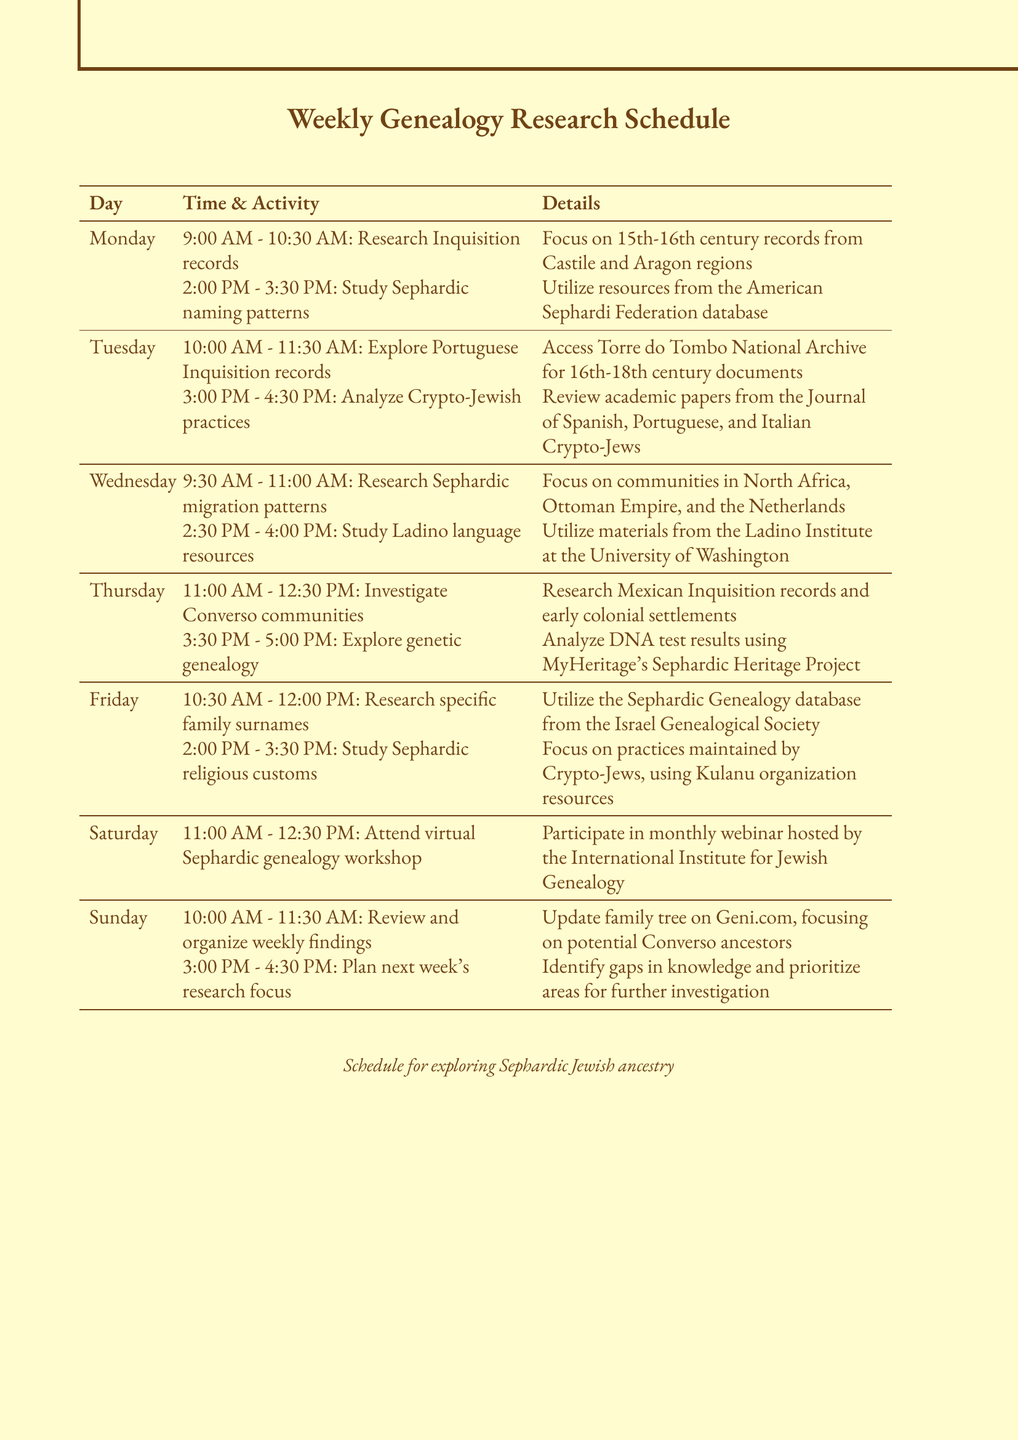What is the first research activity on Monday? The document lists "Research Inquisition records" as the first activity on Monday from 9:00 AM to 10:30 AM.
Answer: Research Inquisition records What is the focus of Tuesday's 10:00 AM activity? The document states that the focus is on "Portuguese Inquisition records".
Answer: Portuguese Inquisition records How many time slots are allocated for research activities on Wednesday? The document outlines two time slots for research activities on Wednesday.
Answer: 2 What are the details for the Thursday afternoon activity? The document specifies that the Thursday afternoon activity is to "Explore genetic genealogy for Sephardic ancestry".
Answer: Analyze DNA test results using MyHeritage's Sephardic Heritage Project What time does the virtual Sephardic genealogy workshop take place on Saturday? The document indicates that the workshop occurs from 11:00 AM to 12:30 PM on Saturday.
Answer: 11:00 AM - 12:30 PM Which organization's resources are used to study Sephardic religious customs on Friday? The document refers to resources from the "Kulanu organization" for studying Sephardic religious customs.
Answer: Kulanu organization How does the schedule propose to handle weekly findings on Sunday? The document suggests to "Review and organize weekly findings" as part of the Sunday activities.
Answer: Review and organize weekly findings What is the primary goal of Sunday's 3:00 PM activity? The document states the goal is to "Plan next week's research focus".
Answer: Plan next week's research focus 